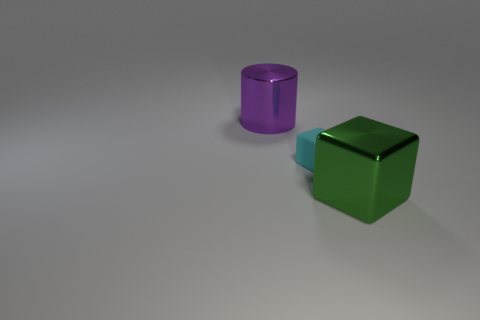What material do the objects in the image seem to be made of? The objects in the image appear to be made of a reflective metal, characterized by the smooth surfaces and clear reflections which indicate a polished finish. 